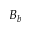<formula> <loc_0><loc_0><loc_500><loc_500>B _ { b }</formula> 